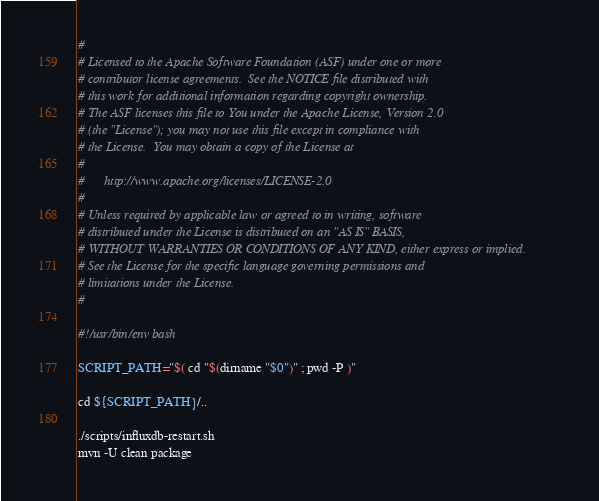Convert code to text. <code><loc_0><loc_0><loc_500><loc_500><_Bash_>#
# Licensed to the Apache Software Foundation (ASF) under one or more
# contributor license agreements.  See the NOTICE file distributed with
# this work for additional information regarding copyright ownership.
# The ASF licenses this file to You under the Apache License, Version 2.0
# (the "License"); you may not use this file except in compliance with
# the License.  You may obtain a copy of the License at
#
#      http://www.apache.org/licenses/LICENSE-2.0
#
# Unless required by applicable law or agreed to in writing, software
# distributed under the License is distributed on an "AS IS" BASIS,
# WITHOUT WARRANTIES OR CONDITIONS OF ANY KIND, either express or implied.
# See the License for the specific language governing permissions and
# limitations under the License.
#

#!/usr/bin/env bash

SCRIPT_PATH="$( cd "$(dirname "$0")" ; pwd -P )"

cd ${SCRIPT_PATH}/..

./scripts/influxdb-restart.sh
mvn -U clean package</code> 